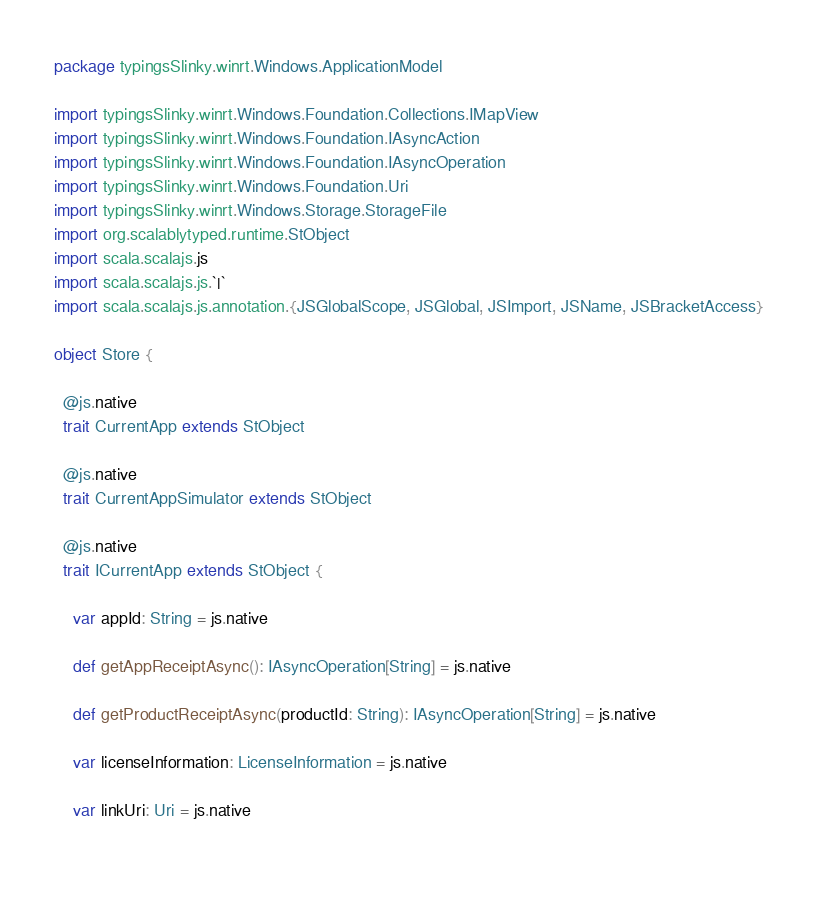<code> <loc_0><loc_0><loc_500><loc_500><_Scala_>package typingsSlinky.winrt.Windows.ApplicationModel

import typingsSlinky.winrt.Windows.Foundation.Collections.IMapView
import typingsSlinky.winrt.Windows.Foundation.IAsyncAction
import typingsSlinky.winrt.Windows.Foundation.IAsyncOperation
import typingsSlinky.winrt.Windows.Foundation.Uri
import typingsSlinky.winrt.Windows.Storage.StorageFile
import org.scalablytyped.runtime.StObject
import scala.scalajs.js
import scala.scalajs.js.`|`
import scala.scalajs.js.annotation.{JSGlobalScope, JSGlobal, JSImport, JSName, JSBracketAccess}

object Store {
  
  @js.native
  trait CurrentApp extends StObject
  
  @js.native
  trait CurrentAppSimulator extends StObject
  
  @js.native
  trait ICurrentApp extends StObject {
    
    var appId: String = js.native
    
    def getAppReceiptAsync(): IAsyncOperation[String] = js.native
    
    def getProductReceiptAsync(productId: String): IAsyncOperation[String] = js.native
    
    var licenseInformation: LicenseInformation = js.native
    
    var linkUri: Uri = js.native
    </code> 